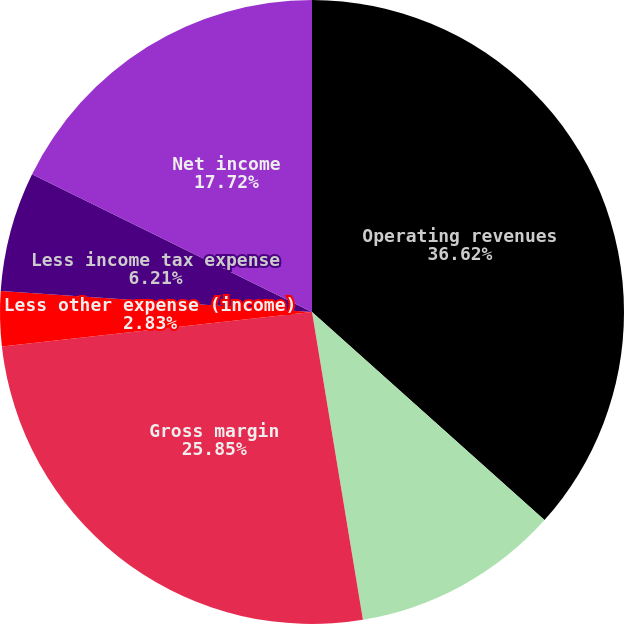Convert chart to OTSL. <chart><loc_0><loc_0><loc_500><loc_500><pie_chart><fcel>Operating revenues<fcel>Less cost of goods sold<fcel>Gross margin<fcel>Less other expense (income)<fcel>Less income tax expense<fcel>Net income<nl><fcel>36.62%<fcel>10.77%<fcel>25.85%<fcel>2.83%<fcel>6.21%<fcel>17.72%<nl></chart> 